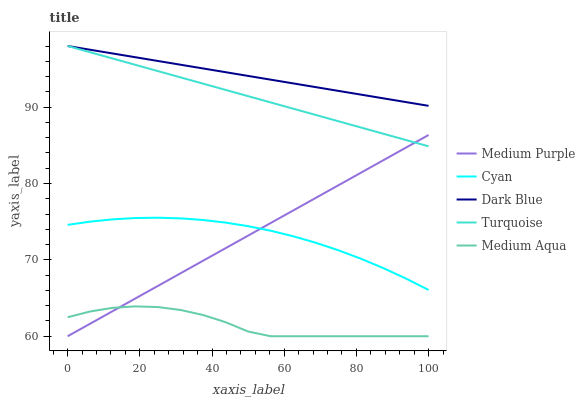Does Medium Aqua have the minimum area under the curve?
Answer yes or no. Yes. Does Dark Blue have the maximum area under the curve?
Answer yes or no. Yes. Does Cyan have the minimum area under the curve?
Answer yes or no. No. Does Cyan have the maximum area under the curve?
Answer yes or no. No. Is Medium Purple the smoothest?
Answer yes or no. Yes. Is Medium Aqua the roughest?
Answer yes or no. Yes. Is Cyan the smoothest?
Answer yes or no. No. Is Cyan the roughest?
Answer yes or no. No. Does Medium Purple have the lowest value?
Answer yes or no. Yes. Does Cyan have the lowest value?
Answer yes or no. No. Does Dark Blue have the highest value?
Answer yes or no. Yes. Does Cyan have the highest value?
Answer yes or no. No. Is Medium Purple less than Dark Blue?
Answer yes or no. Yes. Is Dark Blue greater than Cyan?
Answer yes or no. Yes. Does Medium Aqua intersect Medium Purple?
Answer yes or no. Yes. Is Medium Aqua less than Medium Purple?
Answer yes or no. No. Is Medium Aqua greater than Medium Purple?
Answer yes or no. No. Does Medium Purple intersect Dark Blue?
Answer yes or no. No. 